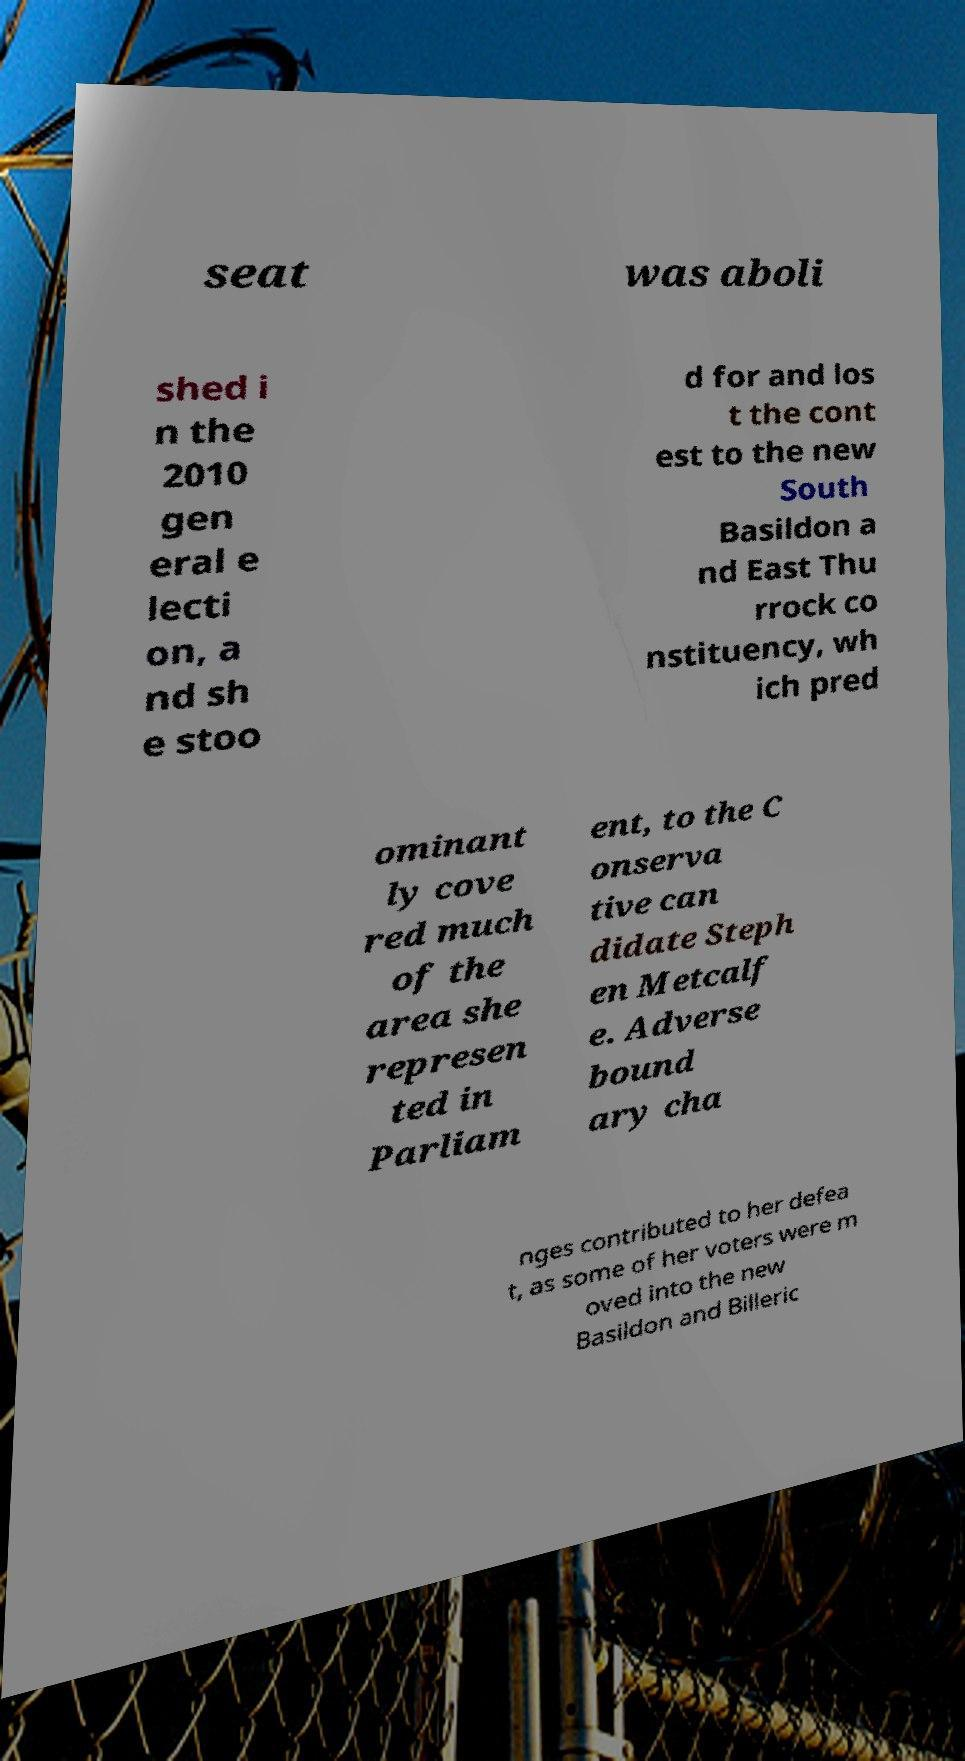Please identify and transcribe the text found in this image. seat was aboli shed i n the 2010 gen eral e lecti on, a nd sh e stoo d for and los t the cont est to the new South Basildon a nd East Thu rrock co nstituency, wh ich pred ominant ly cove red much of the area she represen ted in Parliam ent, to the C onserva tive can didate Steph en Metcalf e. Adverse bound ary cha nges contributed to her defea t, as some of her voters were m oved into the new Basildon and Billeric 